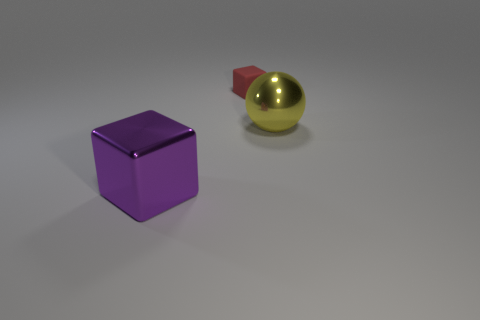Add 2 large yellow matte cylinders. How many objects exist? 5 Subtract all blocks. How many objects are left? 1 Add 3 big purple things. How many big purple things exist? 4 Subtract 0 blue cylinders. How many objects are left? 3 Subtract all large yellow metal balls. Subtract all tiny gray metallic cylinders. How many objects are left? 2 Add 1 tiny red objects. How many tiny red objects are left? 2 